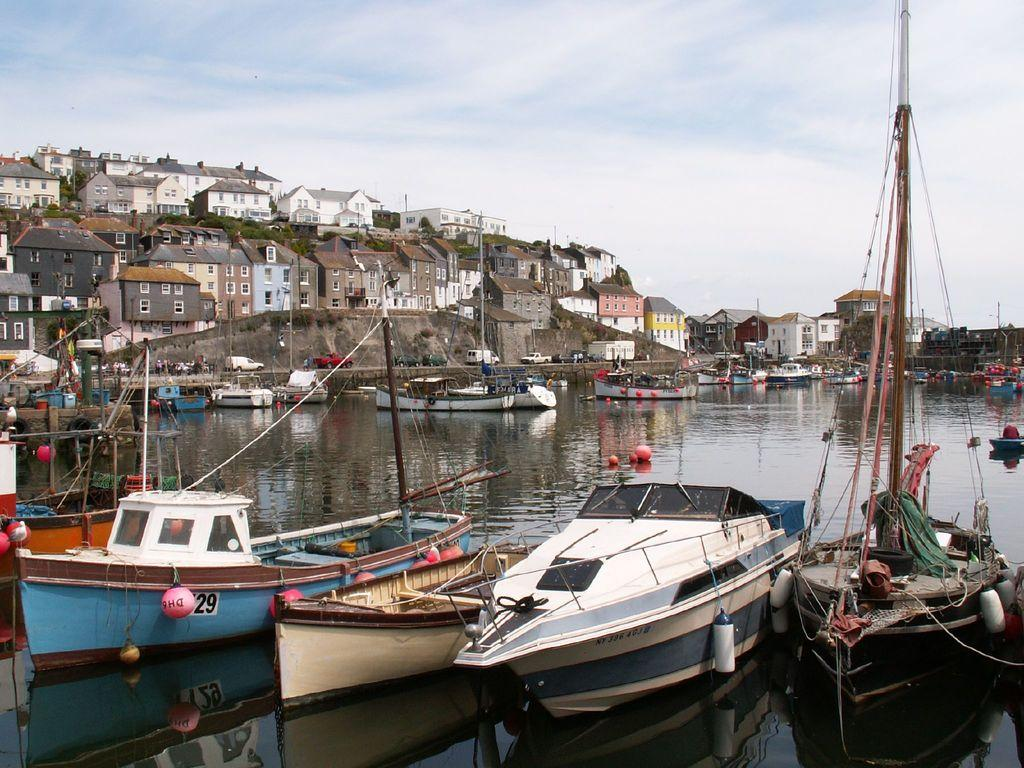What type of structures can be seen in the image? There are buildings in the image. What else can be seen besides buildings? There are objects, windows, trees, vehicles, and the sky visible in the image. Are there any water-based vehicles in the image? Yes, there are boats on the water surface in the image. What is the hand doing in the image? There is no hand present in the image. How does the motion of the vehicles affect the stomach in the image? There is no indication of any motion or stomach in the image; it only shows stationary vehicles. 